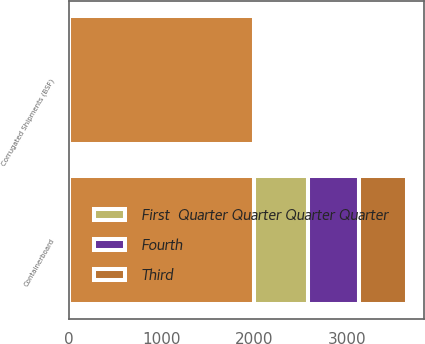Convert chart. <chart><loc_0><loc_0><loc_500><loc_500><stacked_bar_chart><ecel><fcel>Containerboard<fcel>Corrugated Shipments (BSF)<nl><fcel>nan<fcel>2002<fcel>2002<nl><fcel>Third<fcel>520<fcel>6.5<nl><fcel>Fourth<fcel>548<fcel>7.2<nl><fcel>First  Quarter Quarter Quarter Quarter<fcel>578<fcel>7.3<nl></chart> 